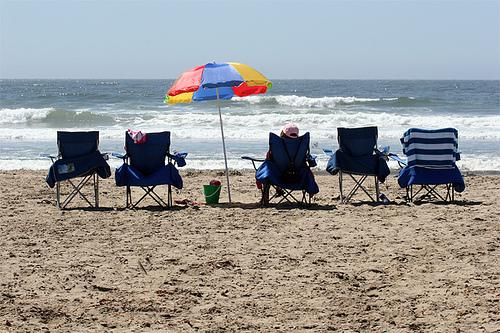Question: where was this picture taken?
Choices:
A. Forest.
B. Jungle.
C. Beach.
D. Park.
Answer with the letter. Answer: C Question: what is in the middle of the picture?
Choices:
A. Apple.
B. Banana.
C. Umbrella.
D. Pineapple.
Answer with the letter. Answer: C Question: how many chairs are there?
Choices:
A. Ten.
B. Twelve.
C. Five.
D. Six.
Answer with the letter. Answer: C 